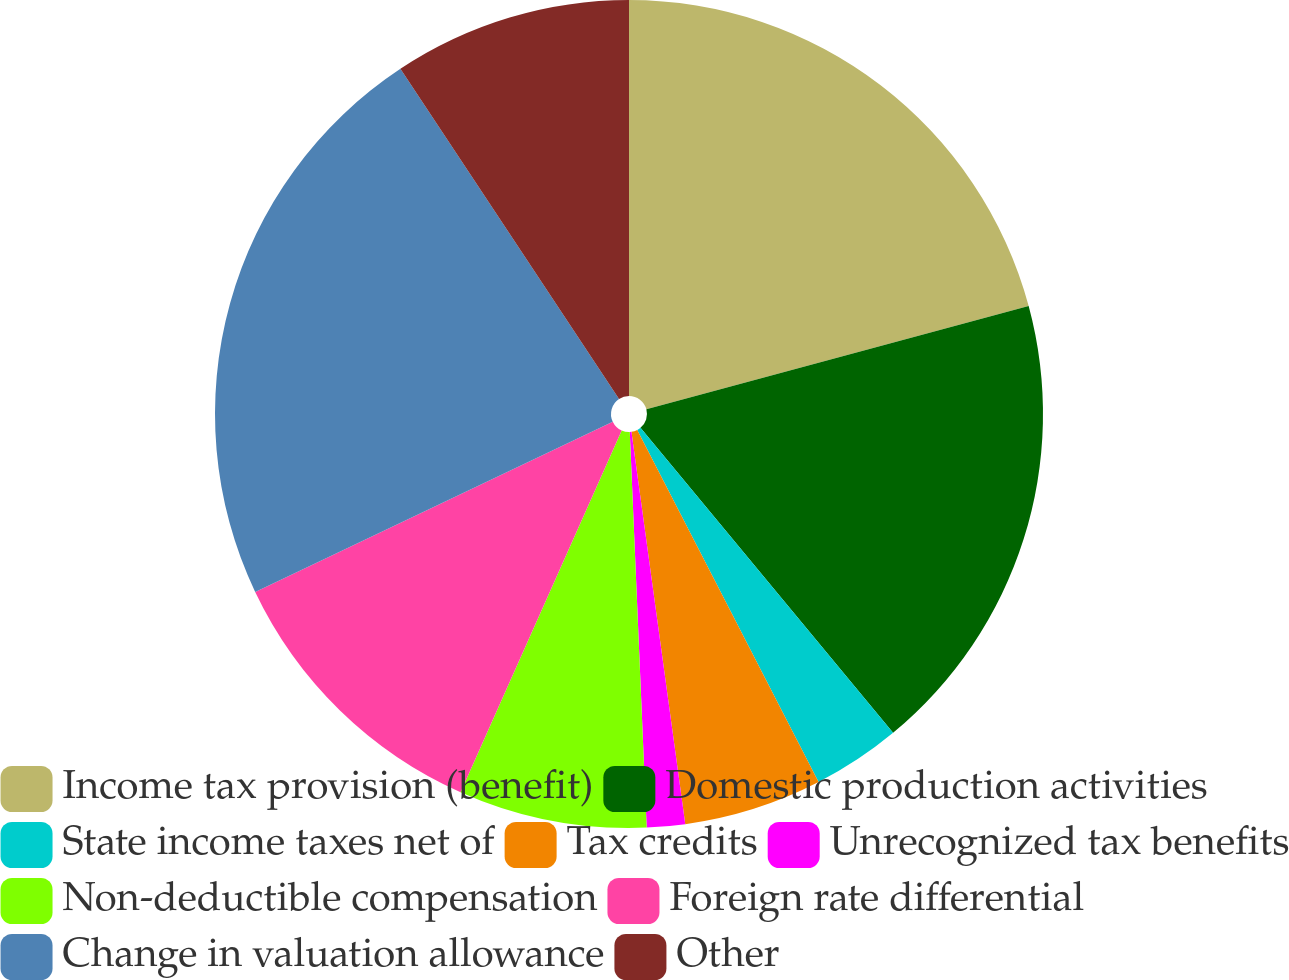Convert chart to OTSL. <chart><loc_0><loc_0><loc_500><loc_500><pie_chart><fcel>Income tax provision (benefit)<fcel>Domestic production activities<fcel>State income taxes net of<fcel>Tax credits<fcel>Unrecognized tax benefits<fcel>Non-deductible compensation<fcel>Foreign rate differential<fcel>Change in valuation allowance<fcel>Other<nl><fcel>20.8%<fcel>18.19%<fcel>3.44%<fcel>5.4%<fcel>1.49%<fcel>7.35%<fcel>11.26%<fcel>22.76%<fcel>9.31%<nl></chart> 